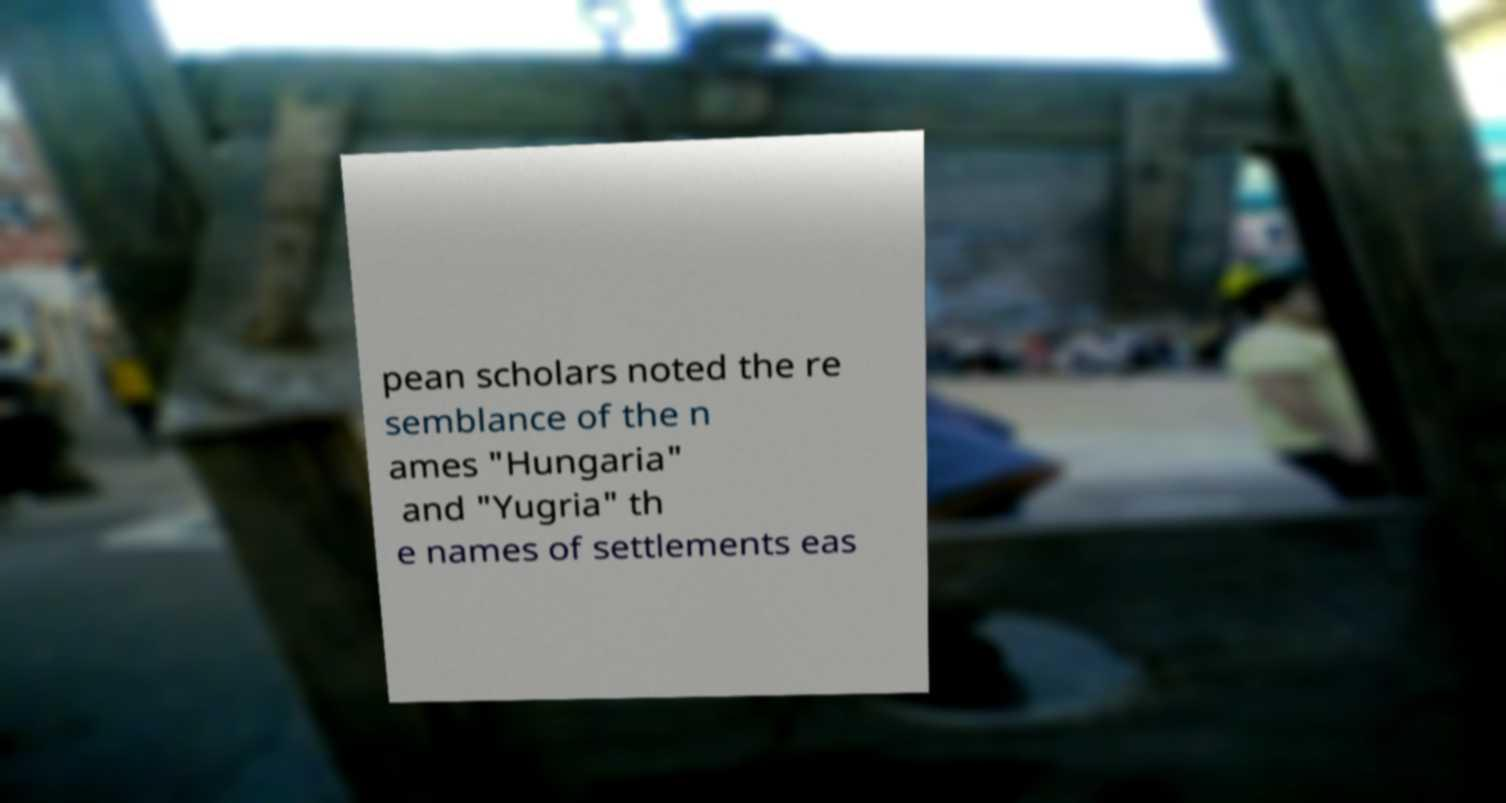For documentation purposes, I need the text within this image transcribed. Could you provide that? pean scholars noted the re semblance of the n ames "Hungaria" and "Yugria" th e names of settlements eas 